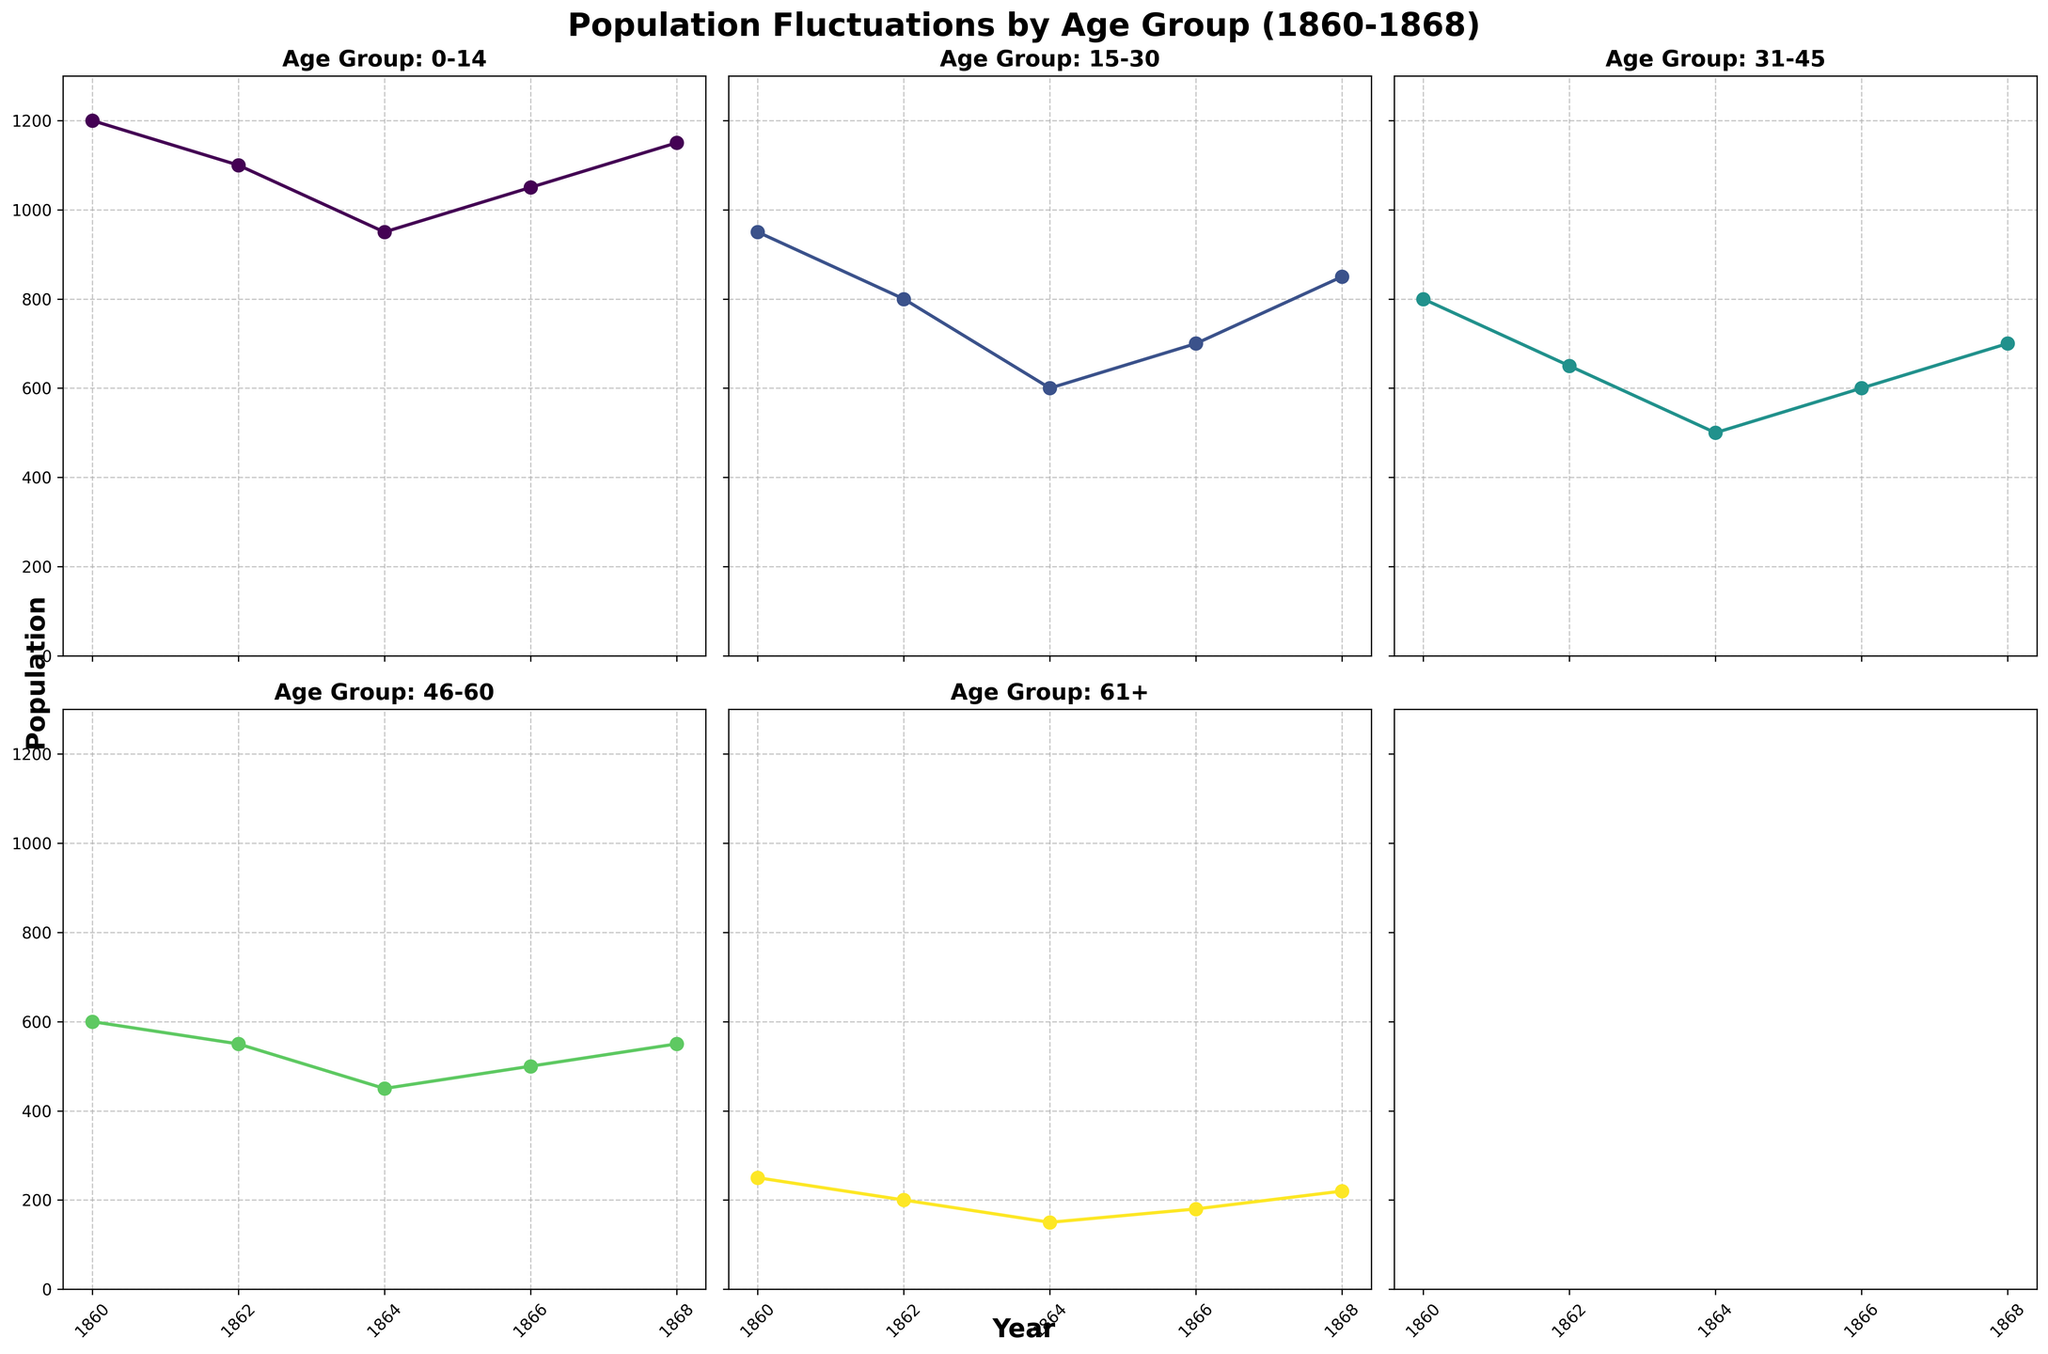what is the title of the plots? The title of the plots is displayed at the top of the figure in large, bold, and centered text. It states, 'Population Fluctuations by Age Group (1860-1868).'
Answer: Population Fluctuations by Age Group (1860-1868) what are the x-axis and y-axis labels? The labels of the x-axis and y-axis are provided at the bottom and left sides of the figure respectively. The x-axis is labeled 'Year' and the y-axis is labeled 'Population.'
Answer: Year, Population which age group had the highest population in 1860? By examining the subplot for the year 1860 across the age groups, it is clear that the 0-14 age group had the highest population, shown by the highest point on the chart for 1860.
Answer: 0-14 how did the population change for the 15-30 age group from 1864 to 1868? In the subplot for the age group 15-30, the population increases from 600 in 1864 to 700 in 1866 and continues to 850 in 1868. This shows a gradual increase over these years.
Answer: Increased which year experienced the largest decline in the 0-14 age group population compared to the previous year? Looking at the subplot for the age group 0-14, we see the biggest decline occurred between 1860 to 1862, where the population fell from 1200 to 1100, a reduction of 100.
Answer: 1862 which age group saw the largest population growth between 1864 and 1868? By comparing the population lines for all age groups between 1864 and 1868, it is seen that the 15-30 age group had an increase from 600 to 850, which is the largest growth (250 people) among all age groups during this period.
Answer: 15-30 in which age group did the population decrease the most from 1860 to 1864? In the subplot for each age group, by comparing the population numbers from 1860 to 1864, the population of the 15-30 age group decreased from 950 to 600, which is a reduction of 350. This is the largest decline over this period.
Answer: 15-30 what was the approximate percentage decrease in the population for the 46-60 age group from 1860 to 1864? To calculate the percentage decrease, use the formula: ((600 - 450) / 600) * 100. The population of the 46-60 age group declined from 600 in 1860 to 450 in 1864. We get (150/600) * 100 = 25%.
Answer: 25% which age group had the smallest population every observed in the years depicted? The subgroup plots show that the age group 61+ had the smallest population, often hitting as low as 150 in the year 1864 – the smallest among all data points.
Answer: 61+ how many age groups had a population below 500 in 1864? By observing the subplots for the year 1864, the age groups 15-30, 31-45, 46-60, and 61+ all had populations below 500. That makes four age groups with populations below 500 in 1864.
Answer: Four 